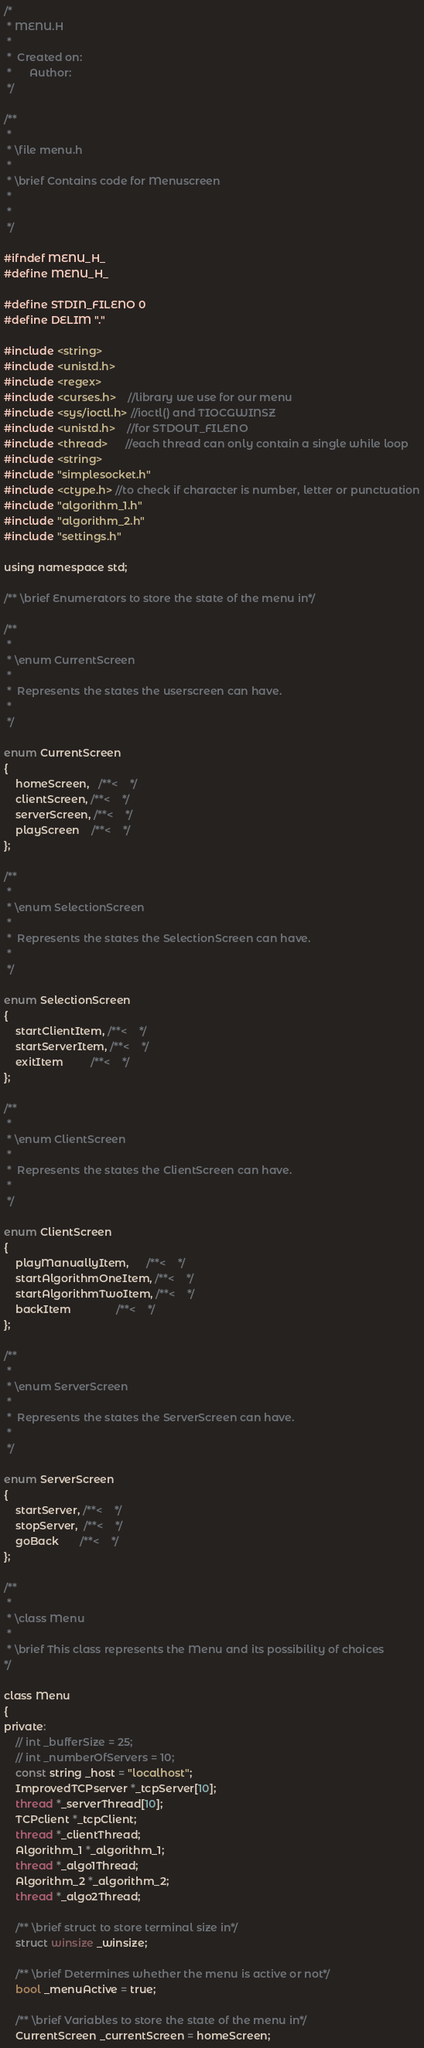<code> <loc_0><loc_0><loc_500><loc_500><_C_>/*
 * MENU.H
 *
 *  Created on: 
 *      Author: 
 */

/**
 *
 * \file menu.h
 *
 * \brief Contains code for Menuscreen
 * 
 *
 */

#ifndef MENU_H_
#define MENU_H_

#define STDIN_FILENO 0
#define DELIM "."

#include <string>
#include <unistd.h>
#include <regex>
#include <curses.h>    //library we use for our menu
#include <sys/ioctl.h> //ioctl() and TIOCGWINSZ
#include <unistd.h>    //for STDOUT_FILENO
#include <thread>      //each thread can only contain a single while loop
#include <string>
#include "simplesocket.h"
#include <ctype.h> //to check if character is number, letter or punctuation
#include "algorithm_1.h"
#include "algorithm_2.h"
#include "settings.h"

using namespace std;

/** \brief Enumerators to store the state of the menu in*/

/**
 *
 * \enum CurrentScreen
 *
 *  Represents the states the userscreen can have.
 *
 */

enum CurrentScreen
{
    homeScreen,   /**<    */
    clientScreen, /**<    */
    serverScreen, /**<    */
    playScreen    /**<    */
};

/**
 *
 * \enum SelectionScreen
 *
 *  Represents the states the SelectionScreen can have.
 *
 */

enum SelectionScreen
{
    startClientItem, /**<    */
    startServerItem, /**<    */
    exitItem         /**<    */
};

/**
 *
 * \enum ClientScreen
 *
 *  Represents the states the ClientScreen can have.
 *
 */

enum ClientScreen
{
    playManuallyItem,      /**<    */
    startAlgorithmOneItem, /**<    */
    startAlgorithmTwoItem, /**<    */
    backItem               /**<    */
};

/**
 *
 * \enum ServerScreen
 *
 *  Represents the states the ServerScreen can have.
 *
 */

enum ServerScreen
{
    startServer, /**<    */
    stopServer,  /**<    */
    goBack       /**<    */
};

/** 
 * 
 * \class Menu
 * 
 * \brief This class represents the Menu and its possibility of choices
*/

class Menu
{
private:
    // int _bufferSize = 25;
    // int _numberOfServers = 10;
    const string _host = "localhost";
    ImprovedTCPserver *_tcpServer[10];
    thread *_serverThread[10];
    TCPclient *_tcpClient;
    thread *_clientThread;
    Algorithm_1 *_algorithm_1;
    thread *_algo1Thread;
    Algorithm_2 *_algorithm_2;
    thread *_algo2Thread;

    /** \brief struct to store terminal size in*/
    struct winsize _winsize;

    /** \brief Determines whether the menu is active or not*/
    bool _menuActive = true;

    /** \brief Variables to store the state of the menu in*/
    CurrentScreen _currentScreen = homeScreen;</code> 